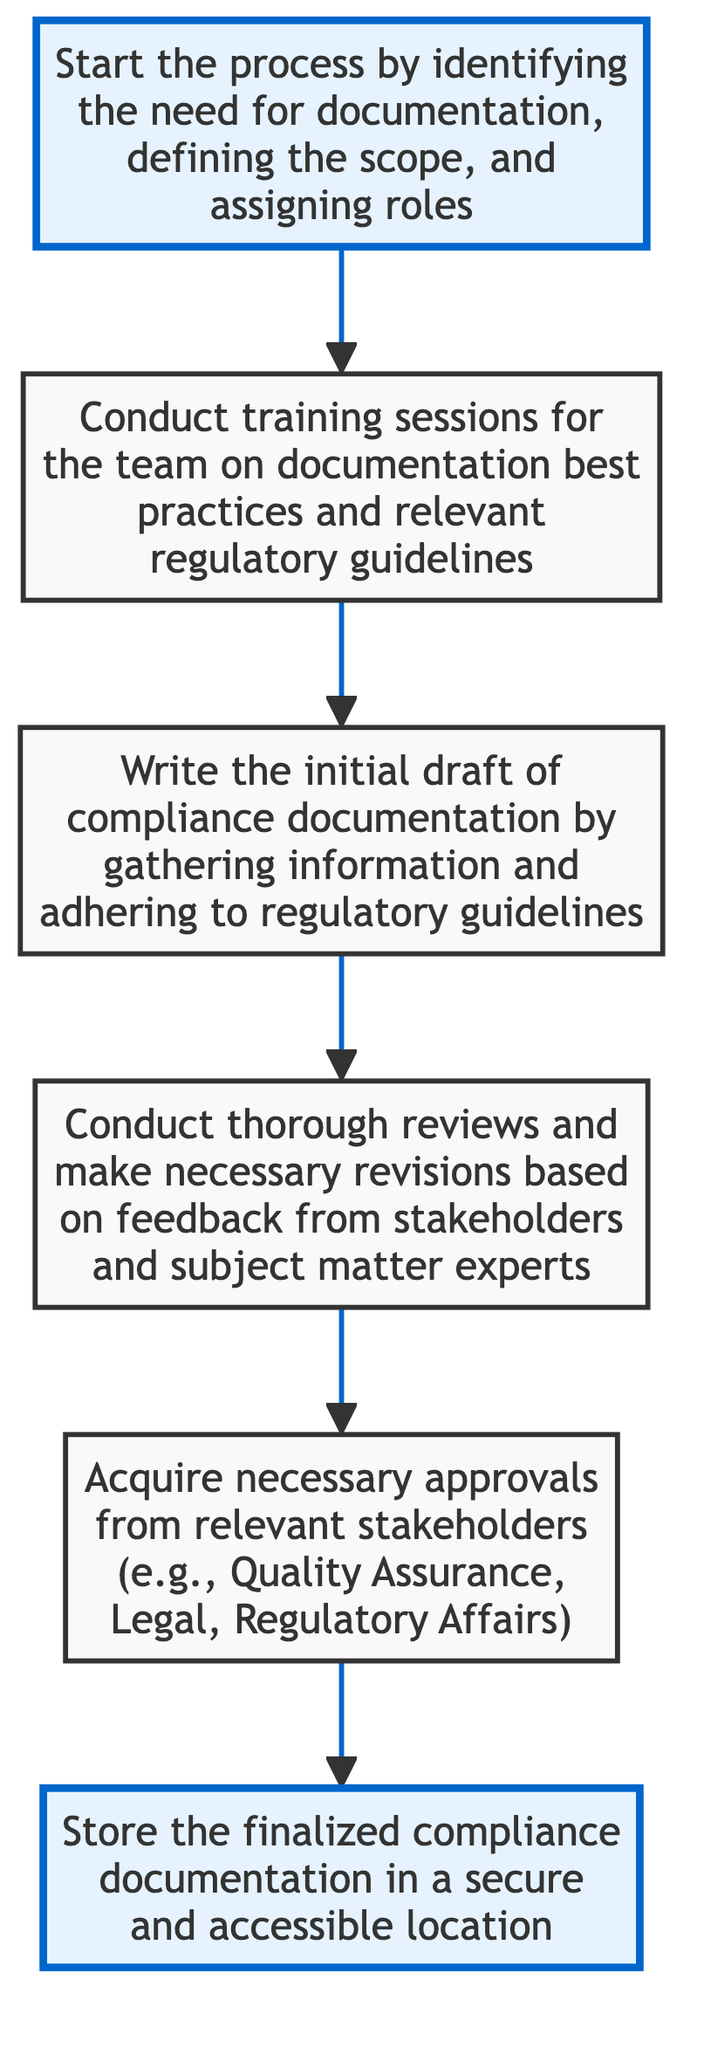What is the first step in the compliance documentation workflow? The first step in the workflow is "Project Kickoff," which starts the process by identifying the need for documentation, defining the scope, and assigning roles.
Answer: Project Kickoff How many total steps are there in the workflow? The workflow consists of five steps: Project Kickoff, Training and Guidelines, Drafting, Review and Revision, Approval, and Archival, totaling six nodes.
Answer: Six What step follows "Drafting" in the compliance documentation workflow? The step that follows "Drafting" is "Review and Revision," where thorough reviews are conducted and necessary revisions are made.
Answer: Review and Revision Which step requires acquisition of approvals from stakeholders? The step requiring acquisition of approvals is "Approval," which involves gaining necessary approvals from relevant stakeholders such as Quality Assurance and Legal.
Answer: Approval What is the final step in the compliance documentation workflow? The final step in the workflow is "Archival," which involves storing the finalized compliance documentation in a secure and accessible location.
Answer: Archival What is the main purpose of the "Training and Guidelines" step? The main purpose of the "Training and Guidelines" step is to conduct training sessions for the team on documentation best practices and relevant regulatory guidelines.
Answer: Conduct training sessions If the "Review and Revision" step does not go well, what is the next step? If the "Review and Revision" step is not satisfactory, the process would loop back to "Drafting" for further revisions before approval can be sought.
Answer: Drafting What happens immediately after the "Approval" step? Immediately after the "Approval" step, the next action is "Archival," where the finalized compliance documentation is stored.
Answer: Archival How does "Project Kickoff" relate to "Training and Guidelines"? "Project Kickoff" initiates the process and leads directly to "Training and Guidelines," indicating that these training sessions are the next step right after kickoff.
Answer: Leads to 